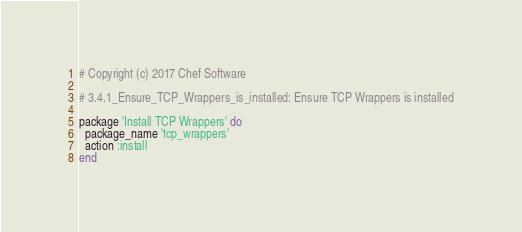Convert code to text. <code><loc_0><loc_0><loc_500><loc_500><_Ruby_># Copyright (c) 2017 Chef Software

# 3.4.1_Ensure_TCP_Wrappers_is_installed: Ensure TCP Wrappers is installed

package 'Install TCP Wrappers' do
  package_name 'tcp_wrappers'
  action :install
end
</code> 